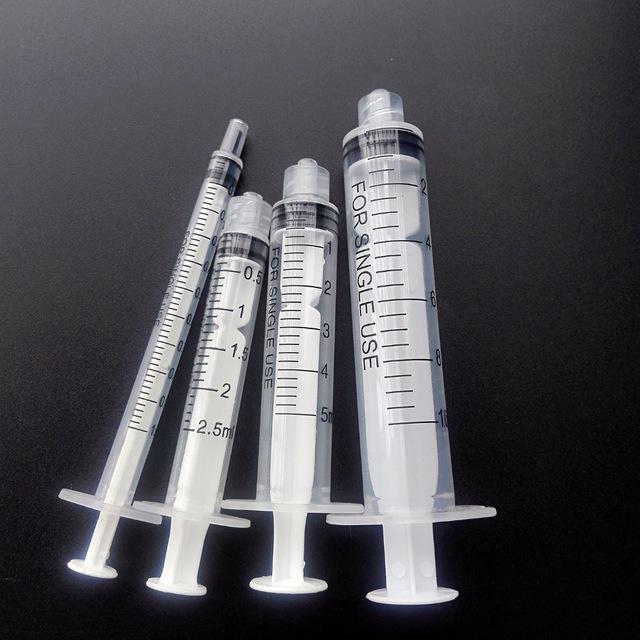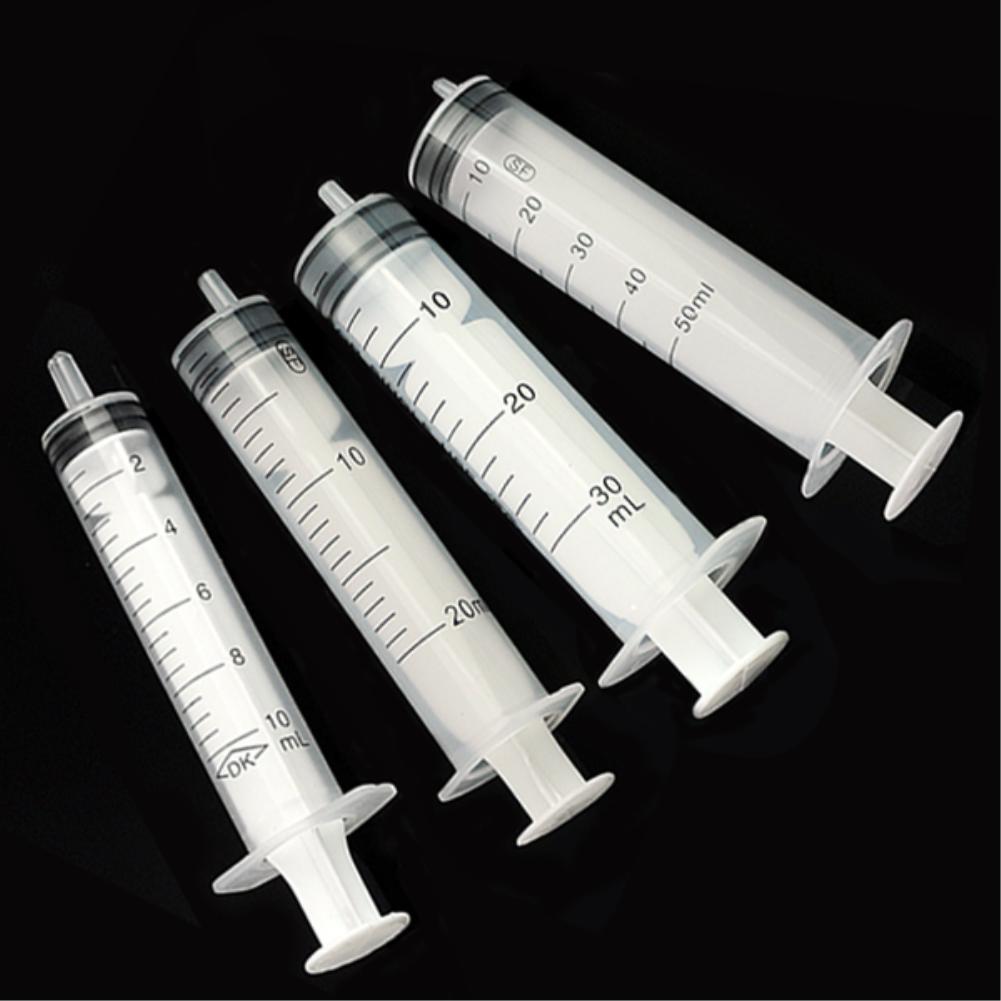The first image is the image on the left, the second image is the image on the right. Examine the images to the left and right. Is the description "In at least one image there is a single empty needle laying down." accurate? Answer yes or no. No. The first image is the image on the left, the second image is the image on the right. Analyze the images presented: Is the assertion "At least one image contains exactly four syringes, and no image contains less than four syringes." valid? Answer yes or no. Yes. 